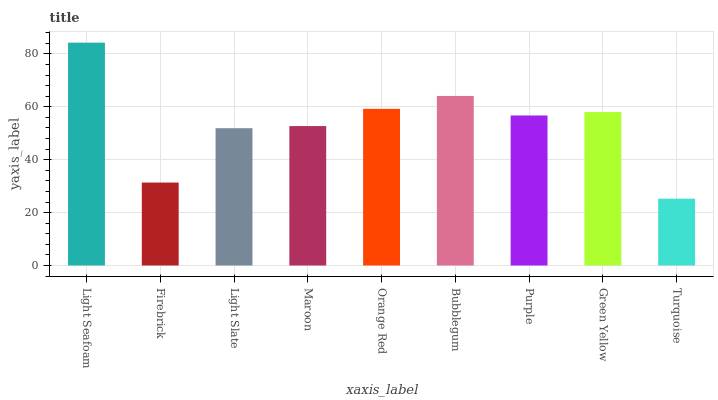Is Firebrick the minimum?
Answer yes or no. No. Is Firebrick the maximum?
Answer yes or no. No. Is Light Seafoam greater than Firebrick?
Answer yes or no. Yes. Is Firebrick less than Light Seafoam?
Answer yes or no. Yes. Is Firebrick greater than Light Seafoam?
Answer yes or no. No. Is Light Seafoam less than Firebrick?
Answer yes or no. No. Is Purple the high median?
Answer yes or no. Yes. Is Purple the low median?
Answer yes or no. Yes. Is Turquoise the high median?
Answer yes or no. No. Is Green Yellow the low median?
Answer yes or no. No. 